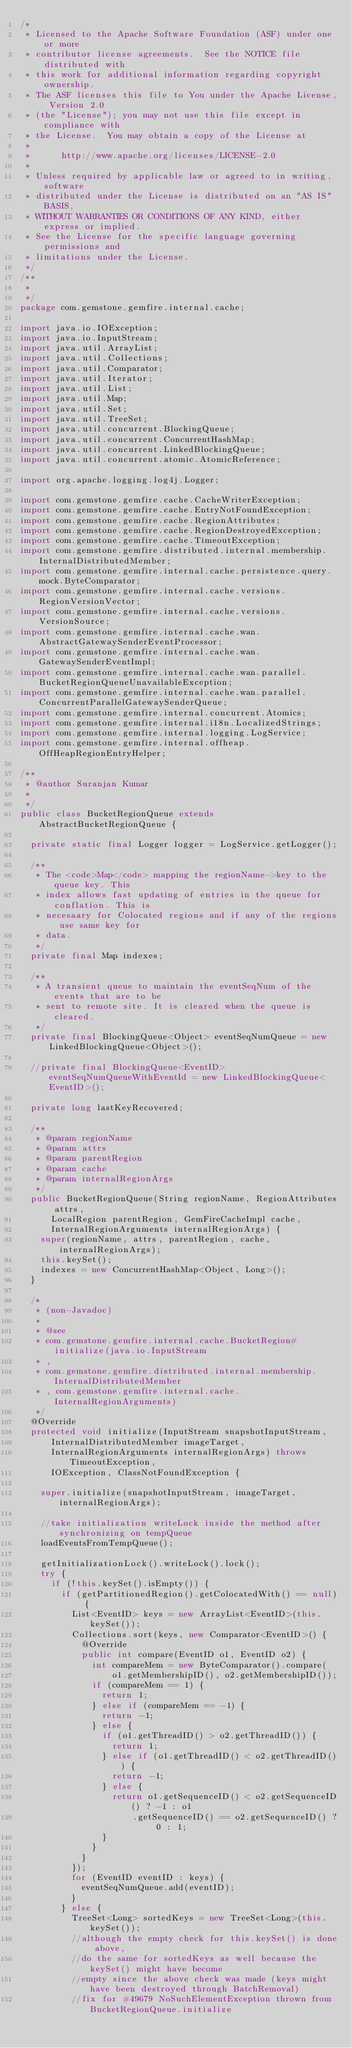<code> <loc_0><loc_0><loc_500><loc_500><_Java_>/*
 * Licensed to the Apache Software Foundation (ASF) under one or more
 * contributor license agreements.  See the NOTICE file distributed with
 * this work for additional information regarding copyright ownership.
 * The ASF licenses this file to You under the Apache License, Version 2.0
 * (the "License"); you may not use this file except in compliance with
 * the License.  You may obtain a copy of the License at
 *
 *      http://www.apache.org/licenses/LICENSE-2.0
 *
 * Unless required by applicable law or agreed to in writing, software
 * distributed under the License is distributed on an "AS IS" BASIS,
 * WITHOUT WARRANTIES OR CONDITIONS OF ANY KIND, either express or implied.
 * See the License for the specific language governing permissions and
 * limitations under the License.
 */
/**
 * 
 */
package com.gemstone.gemfire.internal.cache;

import java.io.IOException;
import java.io.InputStream;
import java.util.ArrayList;
import java.util.Collections;
import java.util.Comparator;
import java.util.Iterator;
import java.util.List;
import java.util.Map;
import java.util.Set;
import java.util.TreeSet;
import java.util.concurrent.BlockingQueue;
import java.util.concurrent.ConcurrentHashMap;
import java.util.concurrent.LinkedBlockingQueue;
import java.util.concurrent.atomic.AtomicReference;

import org.apache.logging.log4j.Logger;

import com.gemstone.gemfire.cache.CacheWriterException;
import com.gemstone.gemfire.cache.EntryNotFoundException;
import com.gemstone.gemfire.cache.RegionAttributes;
import com.gemstone.gemfire.cache.RegionDestroyedException;
import com.gemstone.gemfire.cache.TimeoutException;
import com.gemstone.gemfire.distributed.internal.membership.InternalDistributedMember;
import com.gemstone.gemfire.internal.cache.persistence.query.mock.ByteComparator;
import com.gemstone.gemfire.internal.cache.versions.RegionVersionVector;
import com.gemstone.gemfire.internal.cache.versions.VersionSource;
import com.gemstone.gemfire.internal.cache.wan.AbstractGatewaySenderEventProcessor;
import com.gemstone.gemfire.internal.cache.wan.GatewaySenderEventImpl;
import com.gemstone.gemfire.internal.cache.wan.parallel.BucketRegionQueueUnavailableException;
import com.gemstone.gemfire.internal.cache.wan.parallel.ConcurrentParallelGatewaySenderQueue;
import com.gemstone.gemfire.internal.concurrent.Atomics;
import com.gemstone.gemfire.internal.i18n.LocalizedStrings;
import com.gemstone.gemfire.internal.logging.LogService;
import com.gemstone.gemfire.internal.offheap.OffHeapRegionEntryHelper;

/**
 * @author Suranjan Kumar
 * 
 */
public class BucketRegionQueue extends AbstractBucketRegionQueue {

  private static final Logger logger = LogService.getLogger();
  
  /**
   * The <code>Map</code> mapping the regionName->key to the queue key. This
   * index allows fast updating of entries in the queue for conflation. This is
   * necesaary for Colocated regions and if any of the regions use same key for
   * data.
   */
  private final Map indexes;

  /**
   * A transient queue to maintain the eventSeqNum of the events that are to be
   * sent to remote site. It is cleared when the queue is cleared.
   */
  private final BlockingQueue<Object> eventSeqNumQueue = new LinkedBlockingQueue<Object>();
  
  //private final BlockingQueue<EventID> eventSeqNumQueueWithEventId = new LinkedBlockingQueue<EventID>();

  private long lastKeyRecovered;

  /**
   * @param regionName 
   * @param attrs
   * @param parentRegion
   * @param cache
   * @param internalRegionArgs
   */
  public BucketRegionQueue(String regionName, RegionAttributes attrs,
      LocalRegion parentRegion, GemFireCacheImpl cache,
      InternalRegionArguments internalRegionArgs) {
    super(regionName, attrs, parentRegion, cache, internalRegionArgs);
    this.keySet();
    indexes = new ConcurrentHashMap<Object, Long>();
  }

  /*
   * (non-Javadoc)
   * 
   * @see
   * com.gemstone.gemfire.internal.cache.BucketRegion#initialize(java.io.InputStream
   * ,
   * com.gemstone.gemfire.distributed.internal.membership.InternalDistributedMember
   * , com.gemstone.gemfire.internal.cache.InternalRegionArguments)
   */
  @Override
  protected void initialize(InputStream snapshotInputStream,
      InternalDistributedMember imageTarget,
      InternalRegionArguments internalRegionArgs) throws TimeoutException,
      IOException, ClassNotFoundException {

    super.initialize(snapshotInputStream, imageTarget, internalRegionArgs);

    //take initialization writeLock inside the method after synchronizing on tempQueue
    loadEventsFromTempQueue();
    
    getInitializationLock().writeLock().lock();
    try {
      if (!this.keySet().isEmpty()) {
        if (getPartitionedRegion().getColocatedWith() == null) {
          List<EventID> keys = new ArrayList<EventID>(this.keySet());
          Collections.sort(keys, new Comparator<EventID>() {
            @Override
            public int compare(EventID o1, EventID o2) {
              int compareMem = new ByteComparator().compare(
                  o1.getMembershipID(), o2.getMembershipID());
              if (compareMem == 1) {
                return 1;
              } else if (compareMem == -1) {
                return -1;
              } else {
                if (o1.getThreadID() > o2.getThreadID()) {
                  return 1;
                } else if (o1.getThreadID() < o2.getThreadID()) {
                  return -1;
                } else {
                  return o1.getSequenceID() < o2.getSequenceID() ? -1 : o1
                      .getSequenceID() == o2.getSequenceID() ? 0 : 1;
                }
              }
            }
          });
          for (EventID eventID : keys) {
            eventSeqNumQueue.add(eventID);
          }
        } else {
          TreeSet<Long> sortedKeys = new TreeSet<Long>(this.keySet());
          //although the empty check for this.keySet() is done above, 
          //do the same for sortedKeys as well because the keySet() might have become 
          //empty since the above check was made (keys might have been destroyed through BatchRemoval)
          //fix for #49679 NoSuchElementException thrown from BucketRegionQueue.initialize</code> 